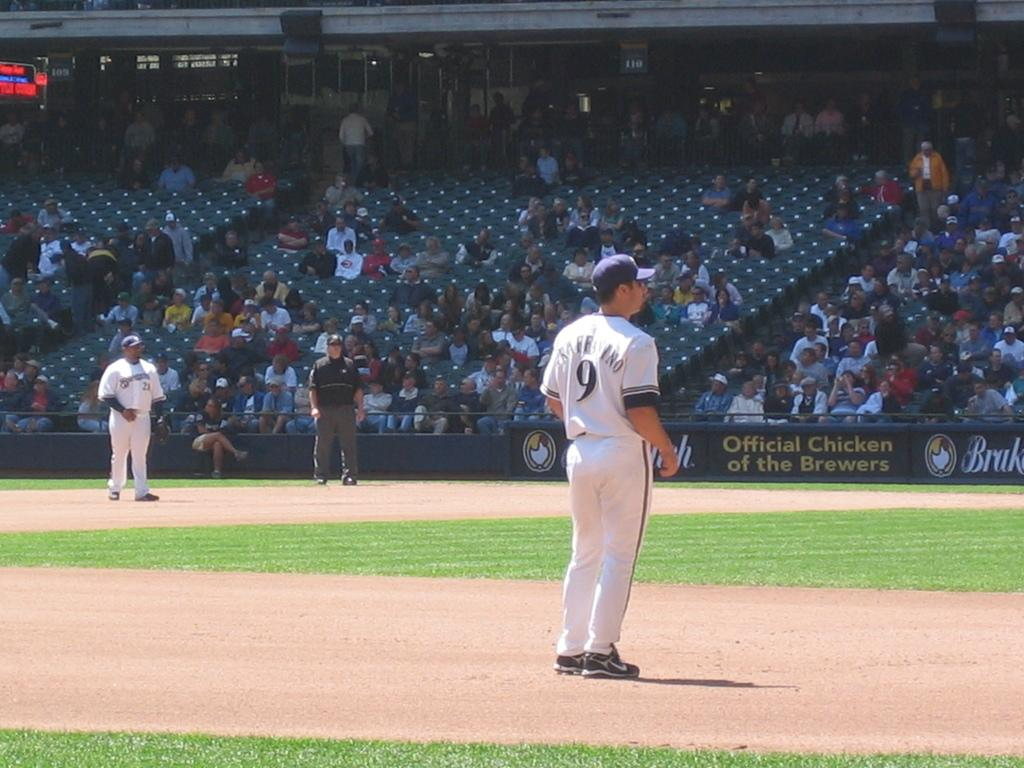<image>
Describe the image concisely. baseball players on a field sponsored by Official Chicken of the Brewers 